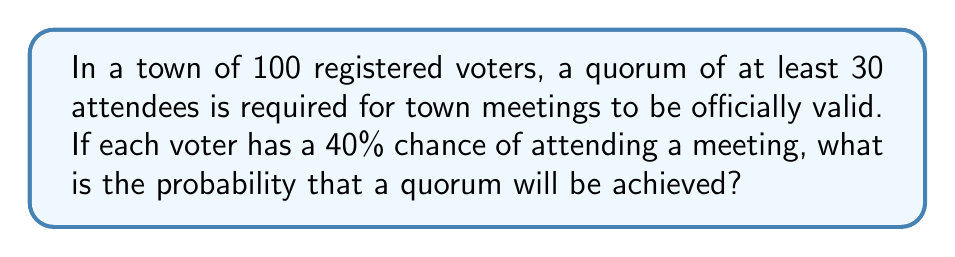Help me with this question. To solve this problem, we can use the binomial distribution:

1) Let $X$ be the number of attendees. $X$ follows a binomial distribution with $n=100$ and $p=0.4$.

2) We need to find $P(X \geq 30)$.

3) Using the complement rule: $P(X \geq 30) = 1 - P(X < 30) = 1 - P(X \leq 29)$

4) The probability mass function for the binomial distribution is:

   $$P(X=k) = \binom{n}{k} p^k (1-p)^{n-k}$$

5) We need to sum this for all values from 0 to 29:

   $$P(X \leq 29) = \sum_{k=0}^{29} \binom{100}{k} (0.4)^k (0.6)^{100-k}$$

6) This sum is computationally intensive, so we would typically use software or a calculator with binomial cumulative distribution function.

7) Using such a tool, we find that $P(X \leq 29) \approx 0.0084$

8) Therefore, $P(X \geq 30) = 1 - 0.0084 \approx 0.9916$
Answer: $0.9916$ or $99.16\%$ 